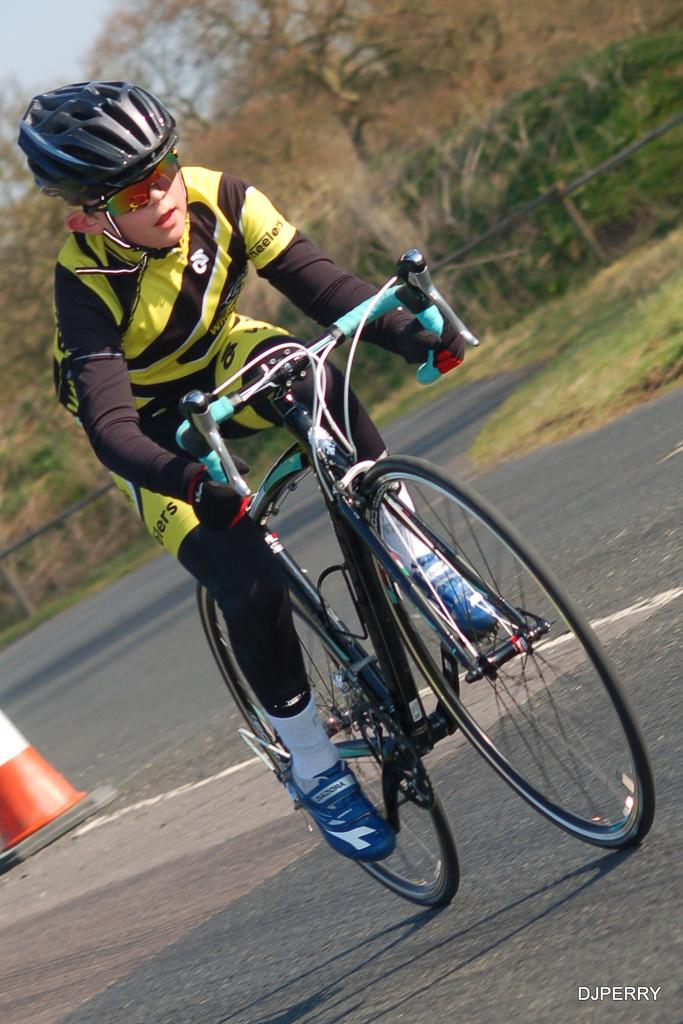What is the person in the image doing? The person is riding a cycle in the image. What safety precaution is the person taking while riding the cycle? The person is wearing a helmet. What can be seen in the background of the image? The sky, trees, grass, a fence, and a traffic pole are visible in the background of the image. What type of work is the person in the image doing? The image does not show the person working or performing any specific job. What kind of shoe is the person wearing while riding the cycle? There is no shoe visible in the image, as the person is wearing a helmet for safety while riding the cycle. 